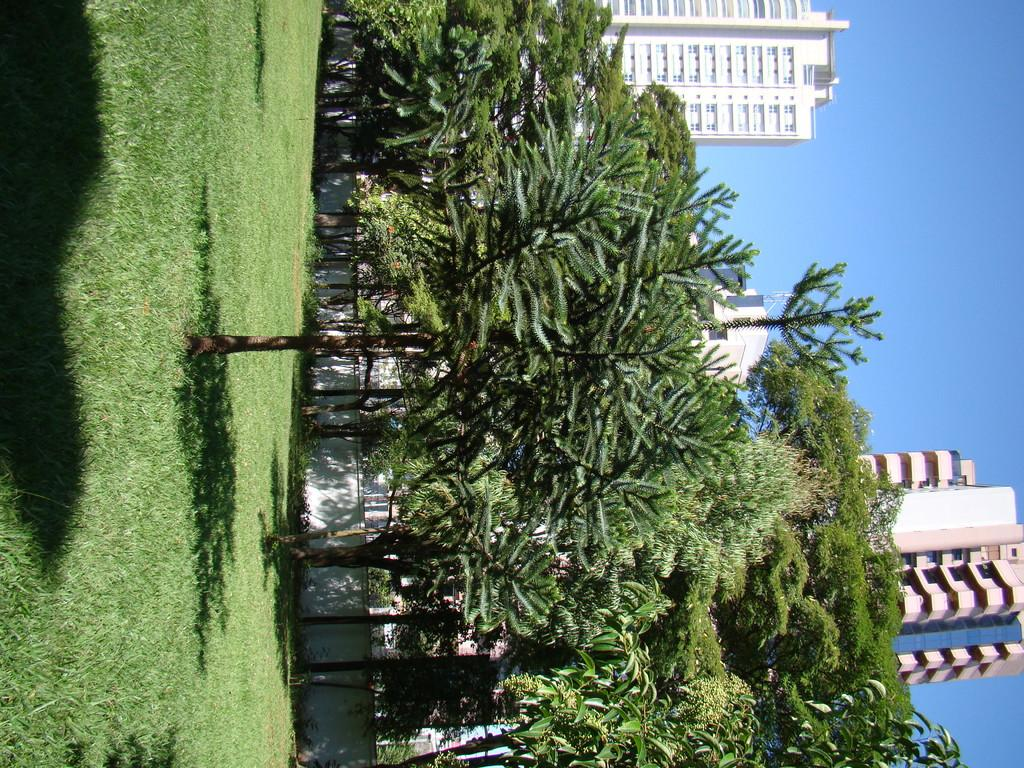What type of vegetation is present on the ground in the image? There is grass on the ground in the image. What other natural elements can be seen in the image? There are trees in the image. What can be seen in the background of the image? There are buildings and the sky visible in the background of the image. What type of songs can be heard coming from the mouth of the tree in the image? There is no mouth or tree singing songs in the image; it features grass, trees, buildings, and the sky. 